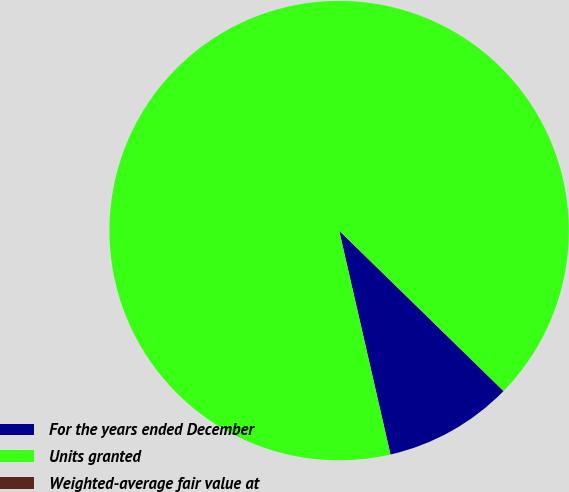Convert chart to OTSL. <chart><loc_0><loc_0><loc_500><loc_500><pie_chart><fcel>For the years ended December<fcel>Units granted<fcel>Weighted-average fair value at<nl><fcel>9.1%<fcel>90.89%<fcel>0.01%<nl></chart> 